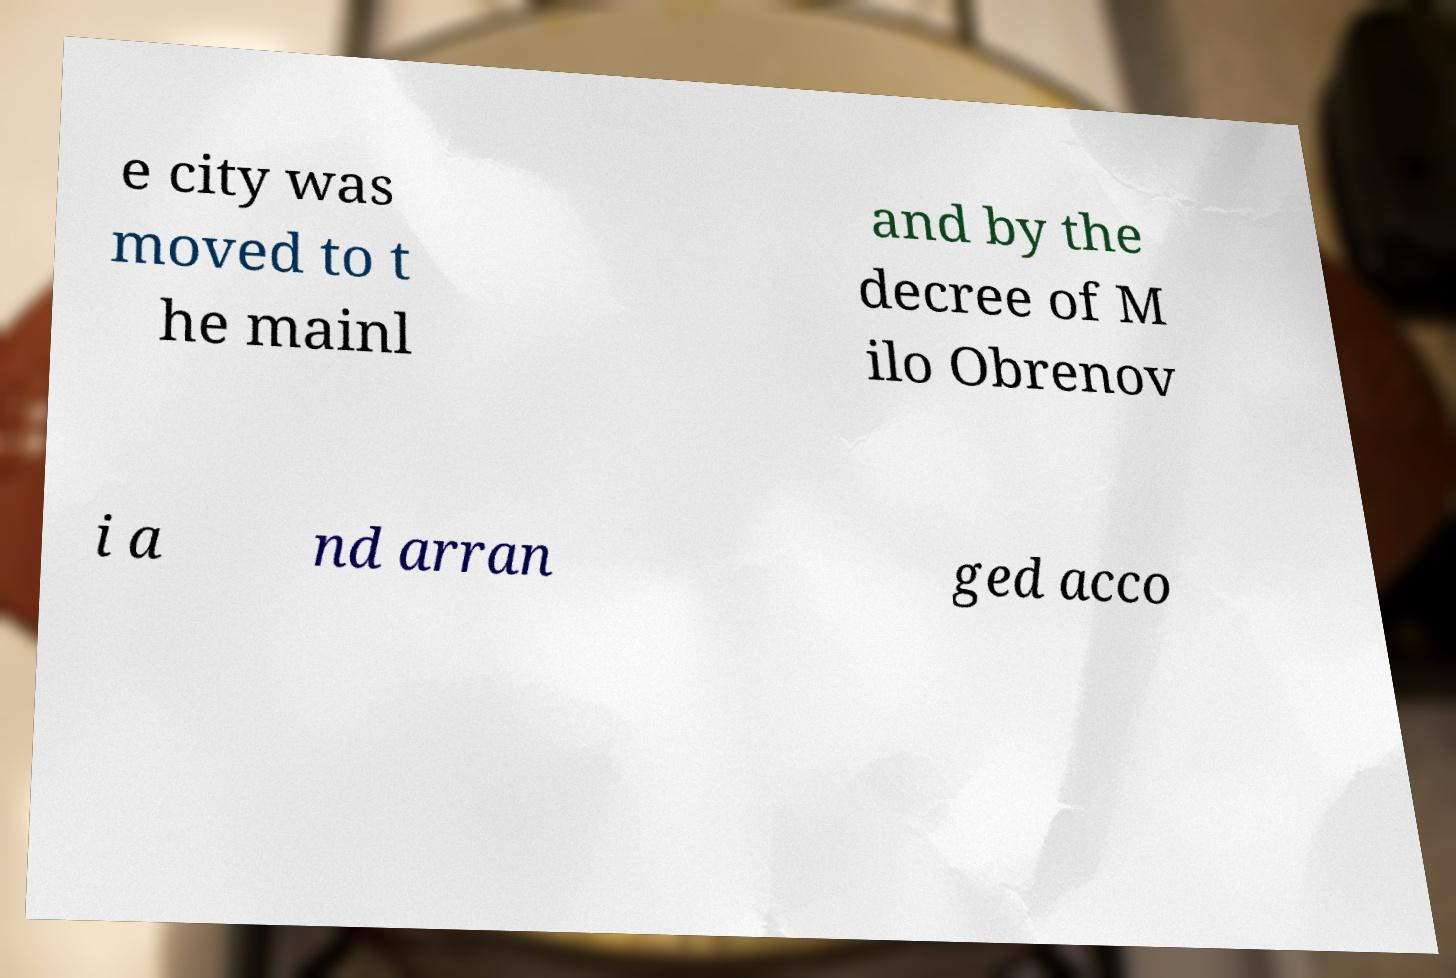Please identify and transcribe the text found in this image. e city was moved to t he mainl and by the decree of M ilo Obrenov i a nd arran ged acco 